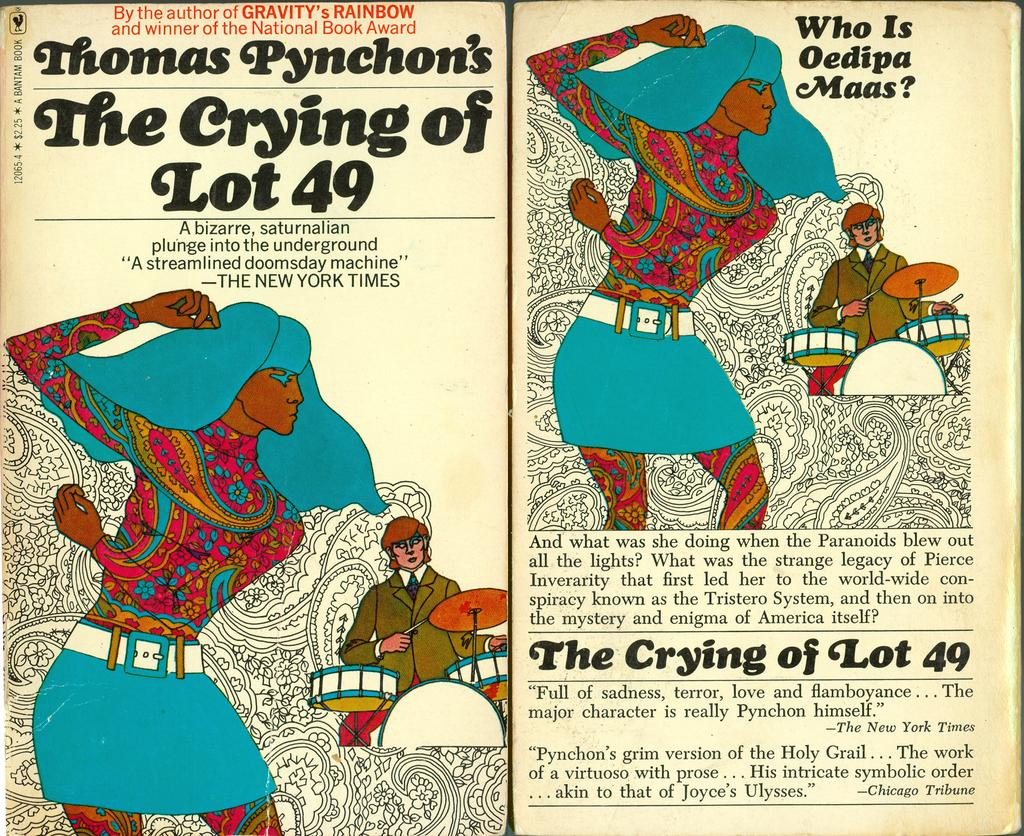What is the main subject of the image? The main subject of the image is an article. What can be found within the article? The article contains pictures and text written on it. What type of curtain is mentioned in the article? There is no mention of a curtain in the article, as the facts provided only mention pictures and text within the article. 